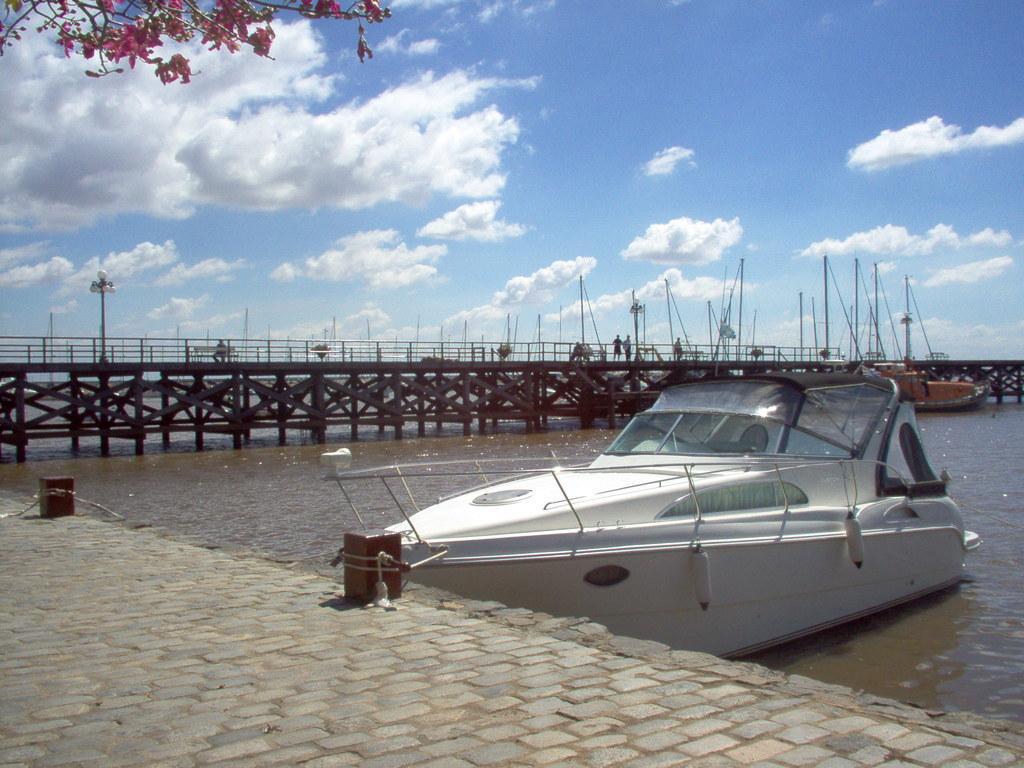Please provide a concise description of this image. In this image there is a white color ship is on the Sea as we can see on the right side of this image. There is a bridge in the background. There is a sky on the top of this image. There are some leaves on the top left corner of this image. There is a floor in the bottom of this image. 